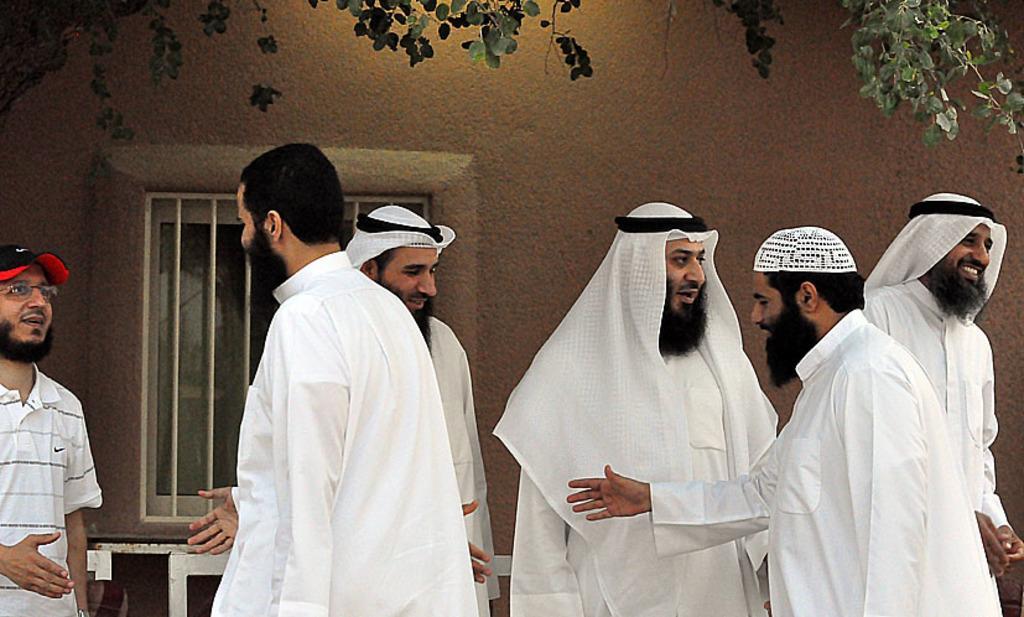Describe this image in one or two sentences. In the center of the image there are people standing. In the background of the image there is a wall with a window. To the left side of the image there is a person wearing a cap. At the top of the image there is tree branch. 